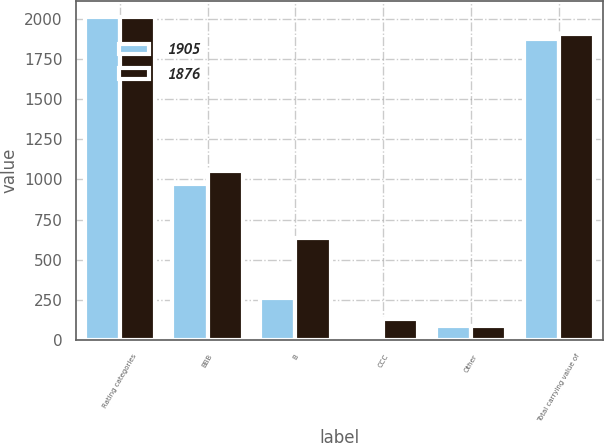<chart> <loc_0><loc_0><loc_500><loc_500><stacked_bar_chart><ecel><fcel>Rating categories<fcel>BBB<fcel>B<fcel>CCC<fcel>Other<fcel>Total carrying value of<nl><fcel>1905<fcel>2015<fcel>973<fcel>258<fcel>23<fcel>86<fcel>1876<nl><fcel>1876<fcel>2014<fcel>1055<fcel>633<fcel>131<fcel>86<fcel>1905<nl></chart> 